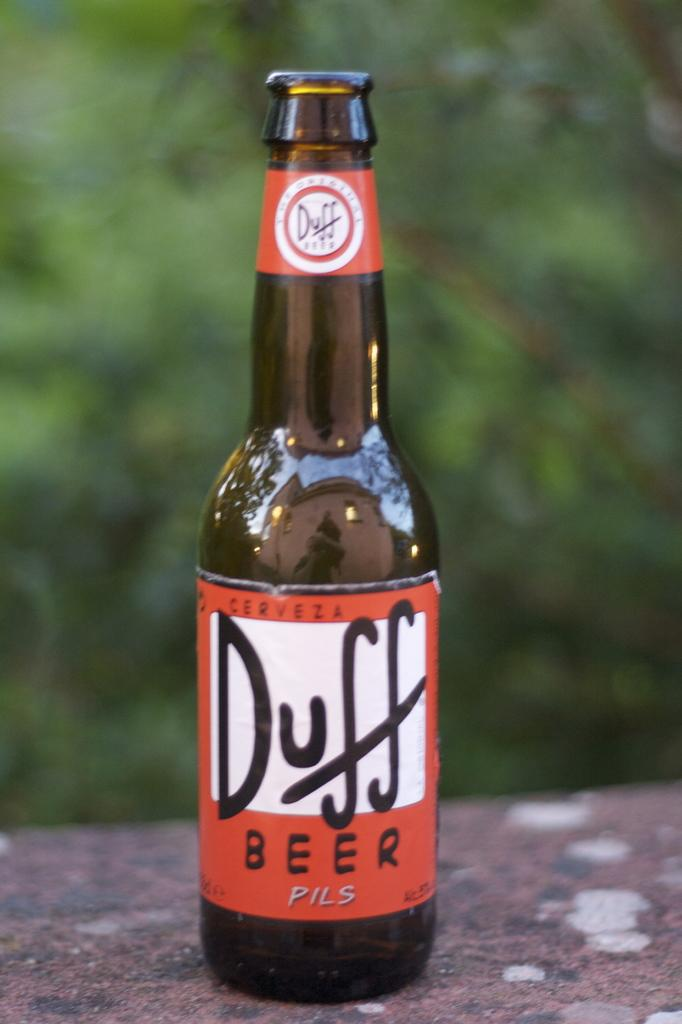<image>
Render a clear and concise summary of the photo. An opened bottle of Duff beers sits on a table. 